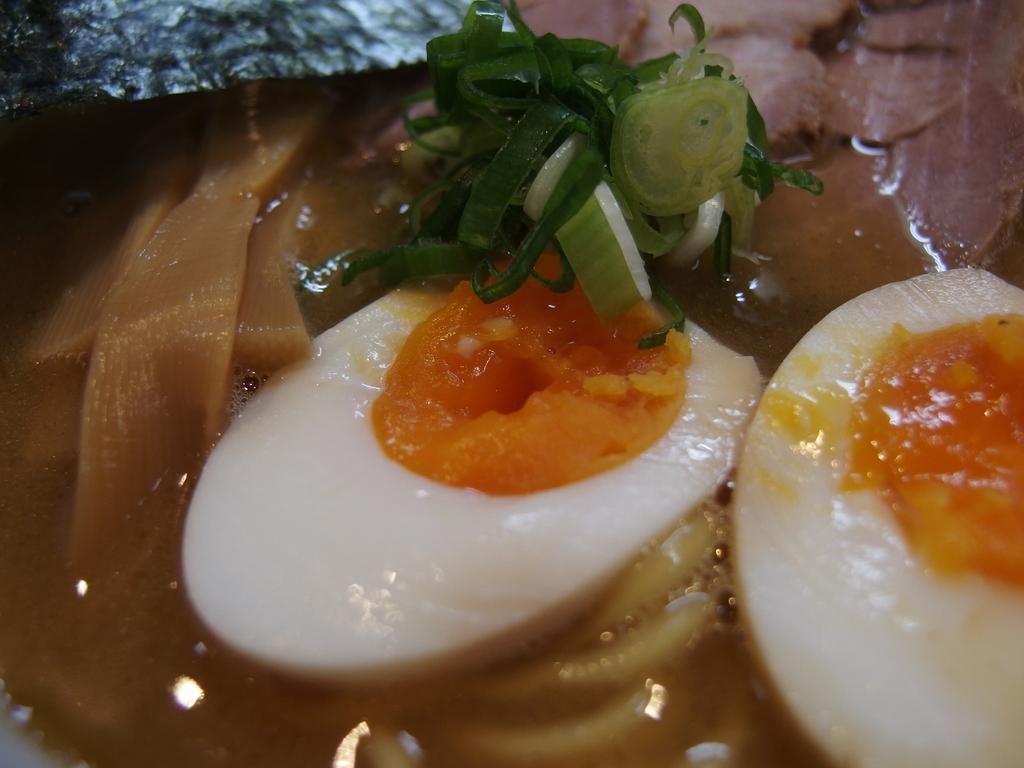How would you summarize this image in a sentence or two? This is a zoomed in picture. In the center we can see the boiled egg and we can see some food items. 